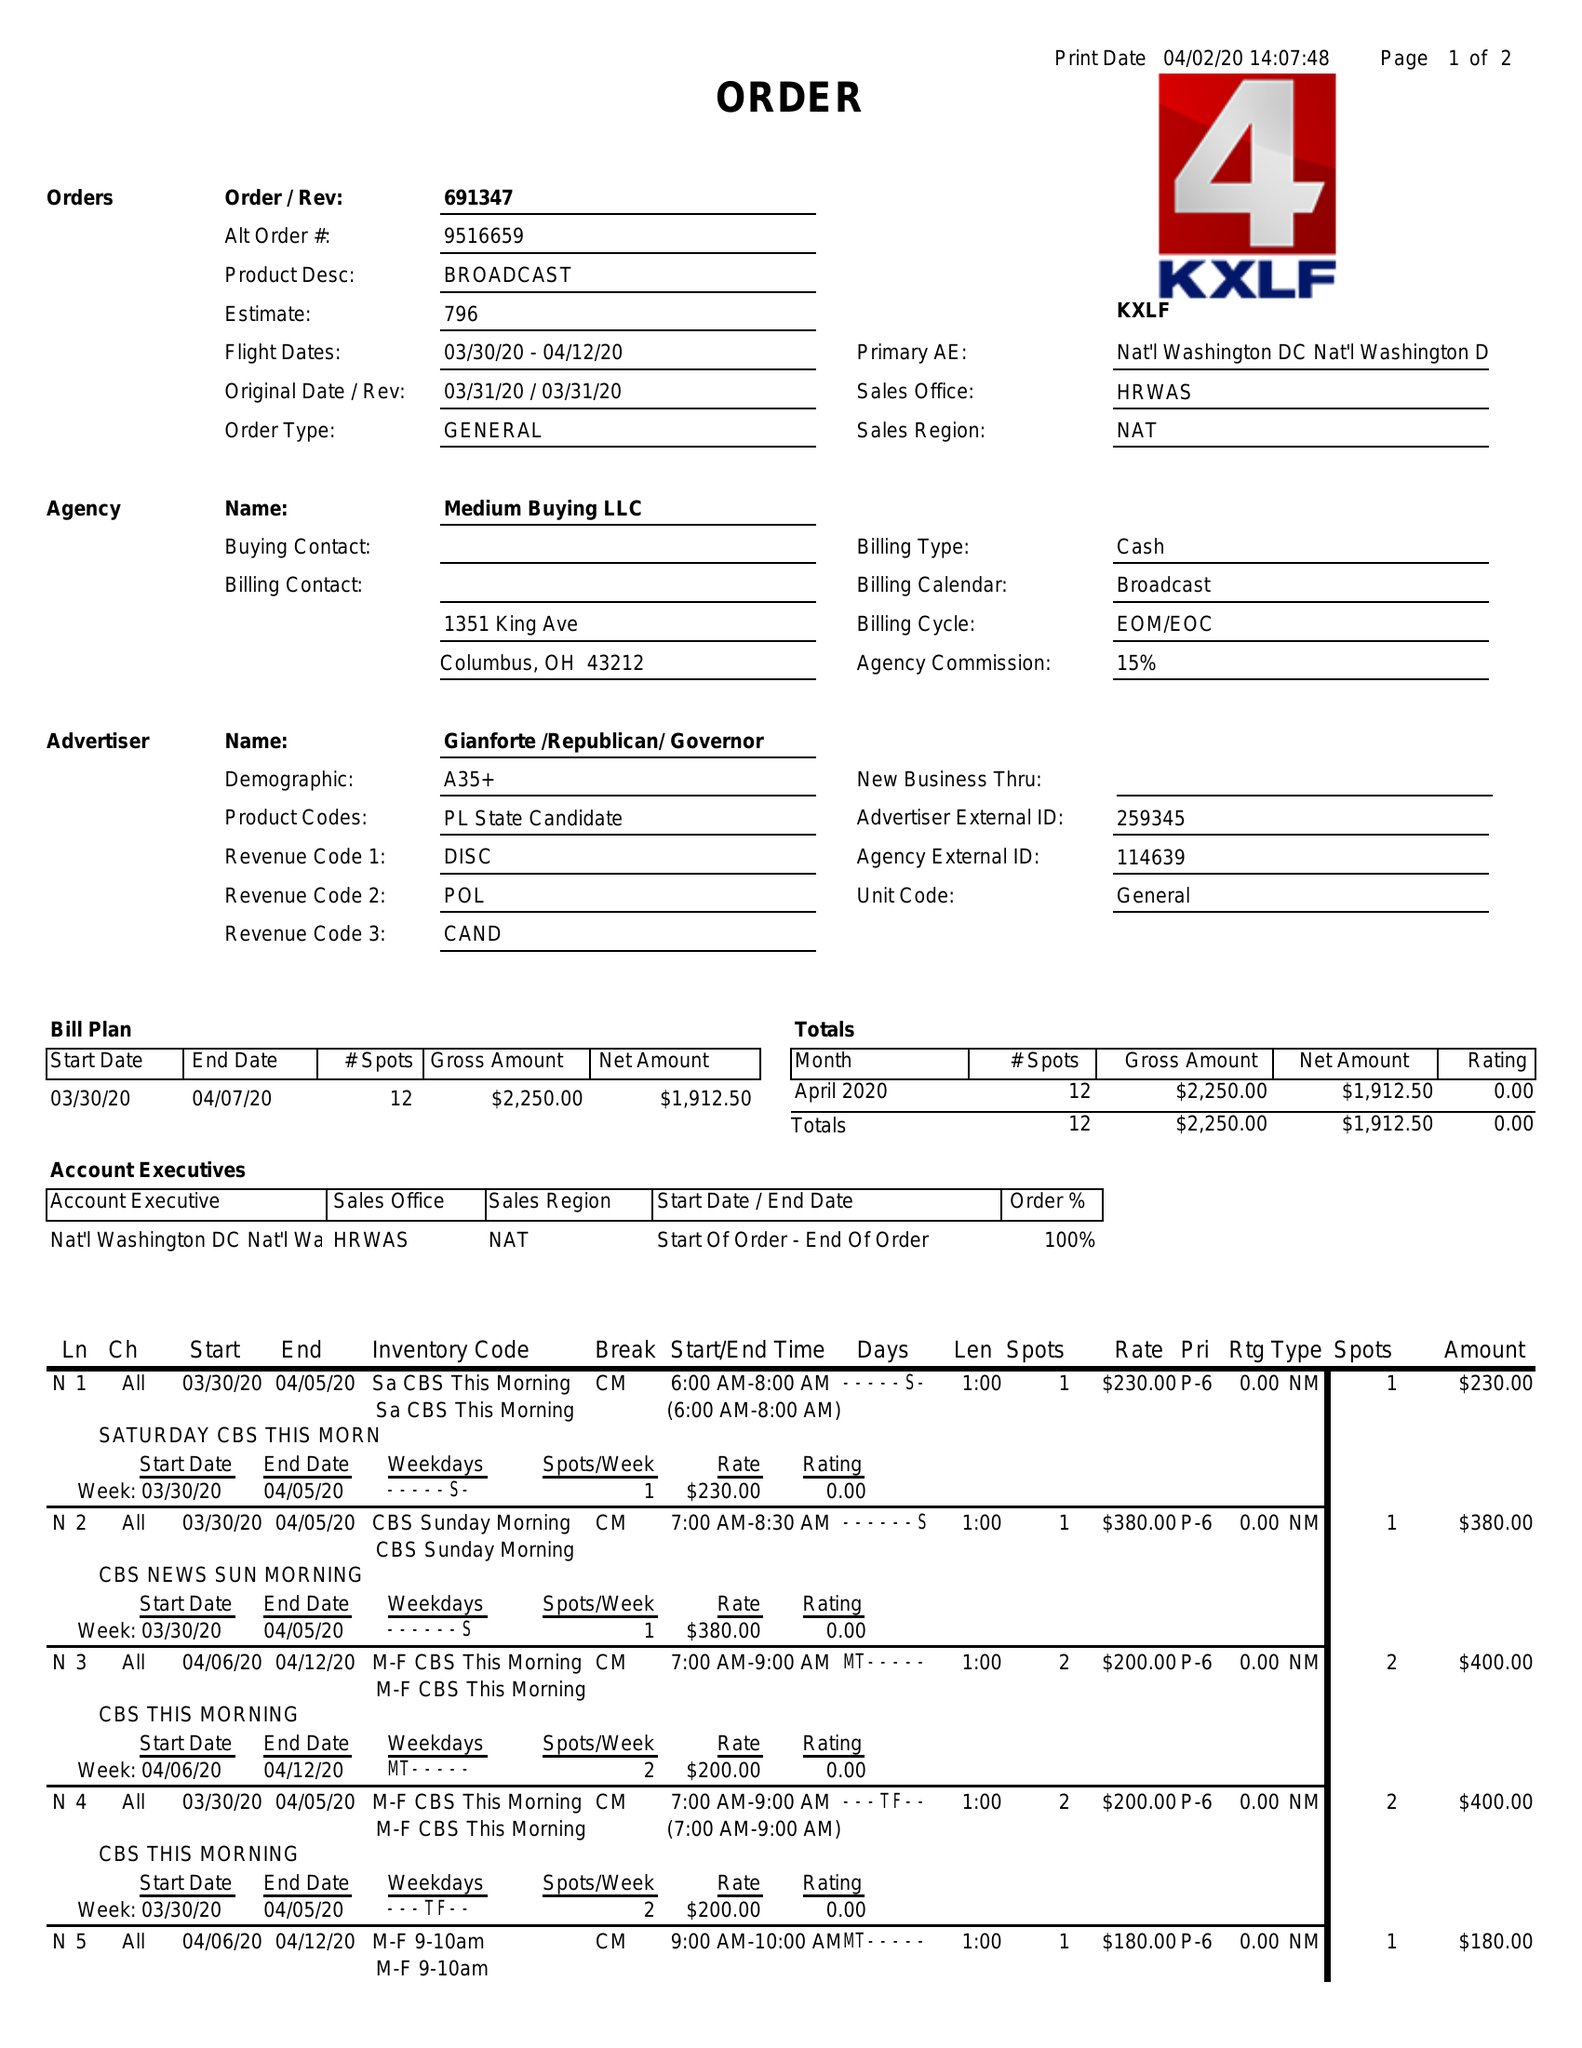What is the value for the flight_from?
Answer the question using a single word or phrase. 03/30/20 